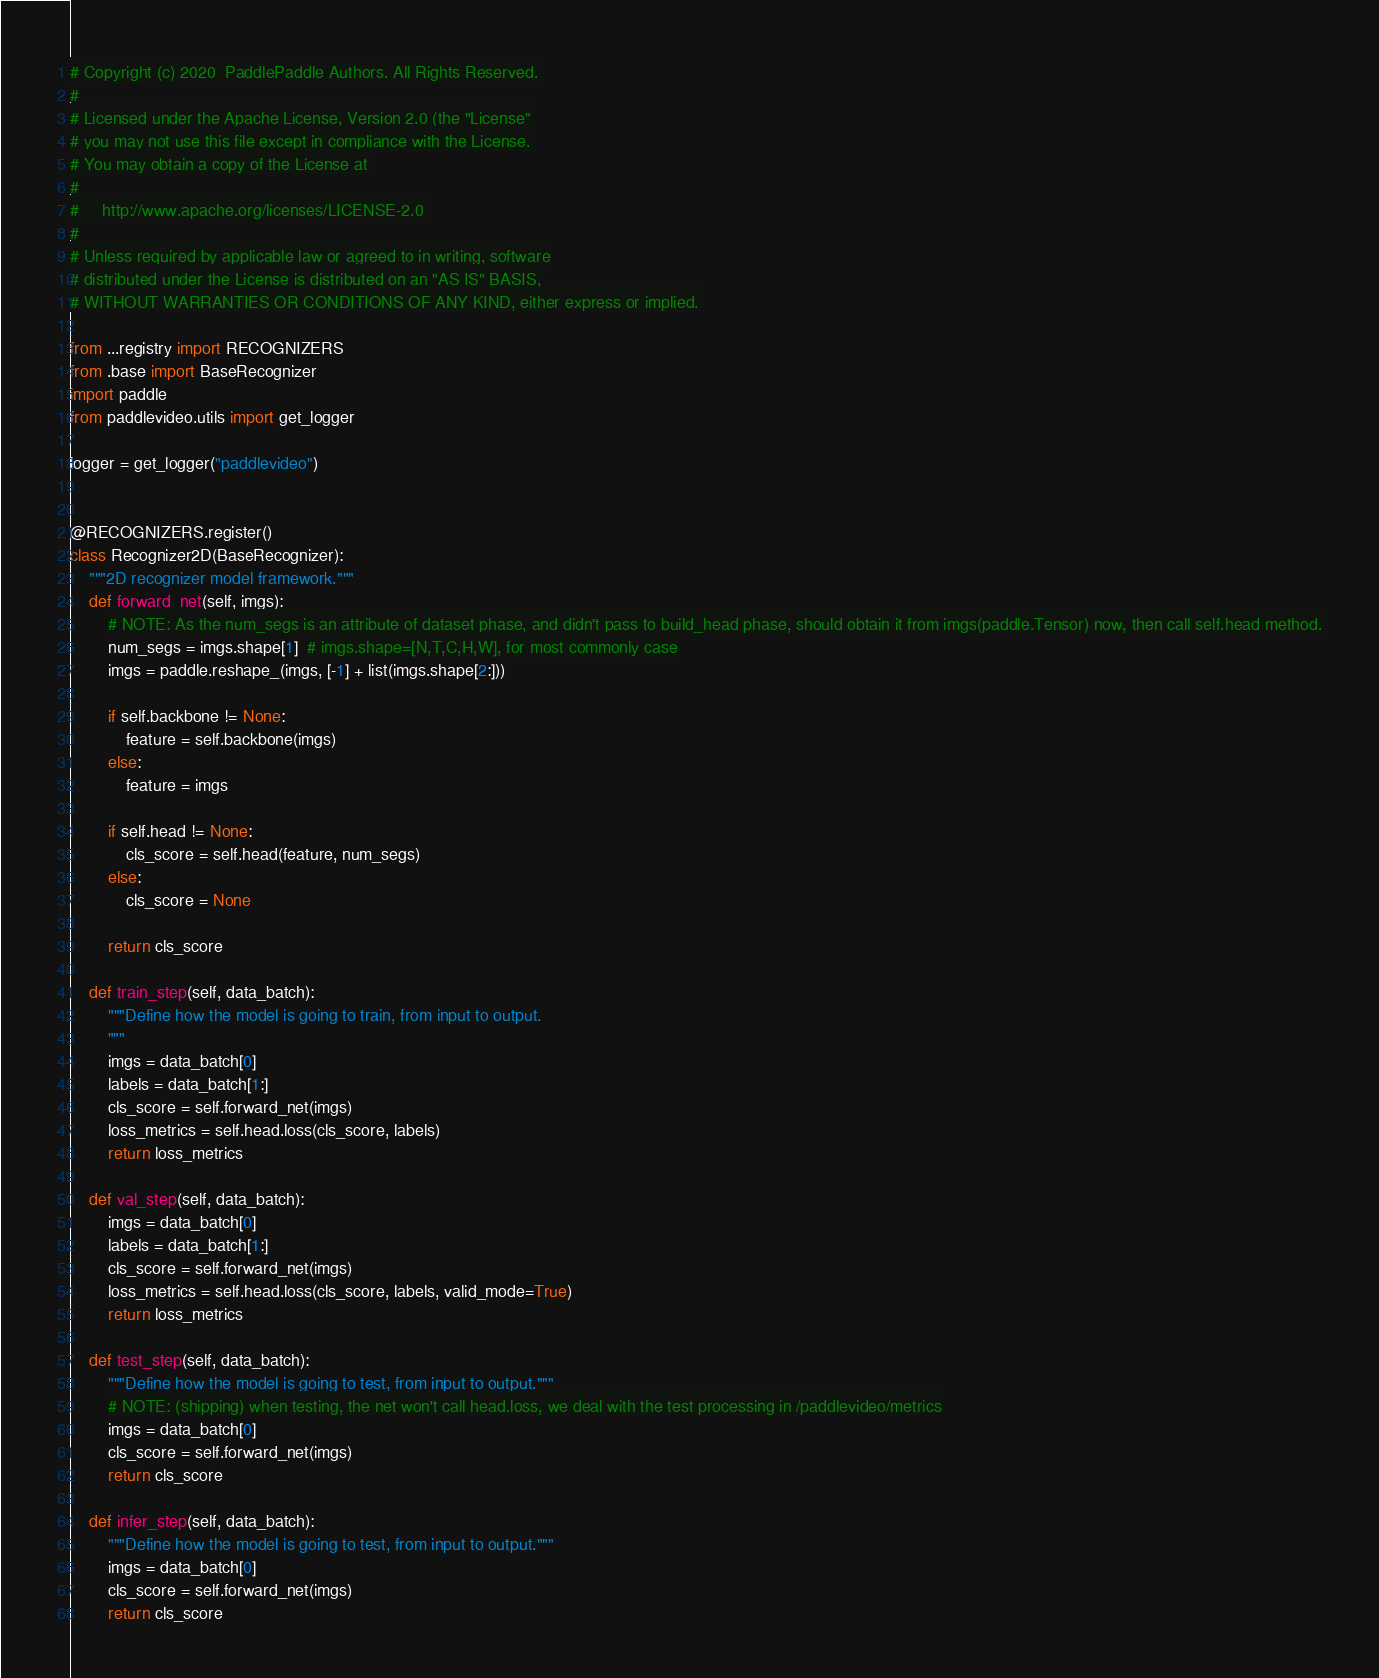<code> <loc_0><loc_0><loc_500><loc_500><_Python_># Copyright (c) 2020  PaddlePaddle Authors. All Rights Reserved.
#
# Licensed under the Apache License, Version 2.0 (the "License"
# you may not use this file except in compliance with the License.
# You may obtain a copy of the License at
#
#     http://www.apache.org/licenses/LICENSE-2.0
#
# Unless required by applicable law or agreed to in writing, software
# distributed under the License is distributed on an "AS IS" BASIS,
# WITHOUT WARRANTIES OR CONDITIONS OF ANY KIND, either express or implied.

from ...registry import RECOGNIZERS
from .base import BaseRecognizer
import paddle
from paddlevideo.utils import get_logger

logger = get_logger("paddlevideo")


@RECOGNIZERS.register()
class Recognizer2D(BaseRecognizer):
    """2D recognizer model framework."""
    def forward_net(self, imgs):
        # NOTE: As the num_segs is an attribute of dataset phase, and didn't pass to build_head phase, should obtain it from imgs(paddle.Tensor) now, then call self.head method.
        num_segs = imgs.shape[1]  # imgs.shape=[N,T,C,H,W], for most commonly case
        imgs = paddle.reshape_(imgs, [-1] + list(imgs.shape[2:]))

        if self.backbone != None:
            feature = self.backbone(imgs)
        else:
            feature = imgs

        if self.head != None:
            cls_score = self.head(feature, num_segs)
        else:
            cls_score = None

        return cls_score

    def train_step(self, data_batch):
        """Define how the model is going to train, from input to output.
        """
        imgs = data_batch[0]
        labels = data_batch[1:]
        cls_score = self.forward_net(imgs)
        loss_metrics = self.head.loss(cls_score, labels)
        return loss_metrics

    def val_step(self, data_batch):
        imgs = data_batch[0]
        labels = data_batch[1:]
        cls_score = self.forward_net(imgs)
        loss_metrics = self.head.loss(cls_score, labels, valid_mode=True)
        return loss_metrics

    def test_step(self, data_batch):
        """Define how the model is going to test, from input to output."""
        # NOTE: (shipping) when testing, the net won't call head.loss, we deal with the test processing in /paddlevideo/metrics
        imgs = data_batch[0]
        cls_score = self.forward_net(imgs)
        return cls_score

    def infer_step(self, data_batch):
        """Define how the model is going to test, from input to output."""
        imgs = data_batch[0]
        cls_score = self.forward_net(imgs)
        return cls_score
</code> 